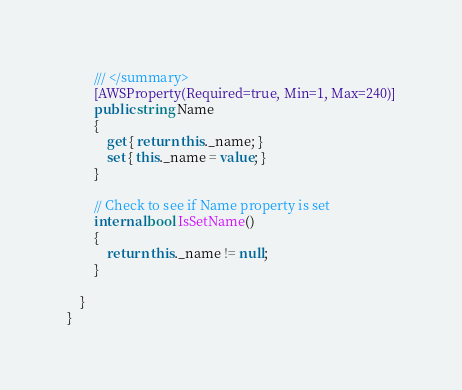<code> <loc_0><loc_0><loc_500><loc_500><_C#_>        /// </summary>
        [AWSProperty(Required=true, Min=1, Max=240)]
        public string Name
        {
            get { return this._name; }
            set { this._name = value; }
        }

        // Check to see if Name property is set
        internal bool IsSetName()
        {
            return this._name != null;
        }

    }
}</code> 